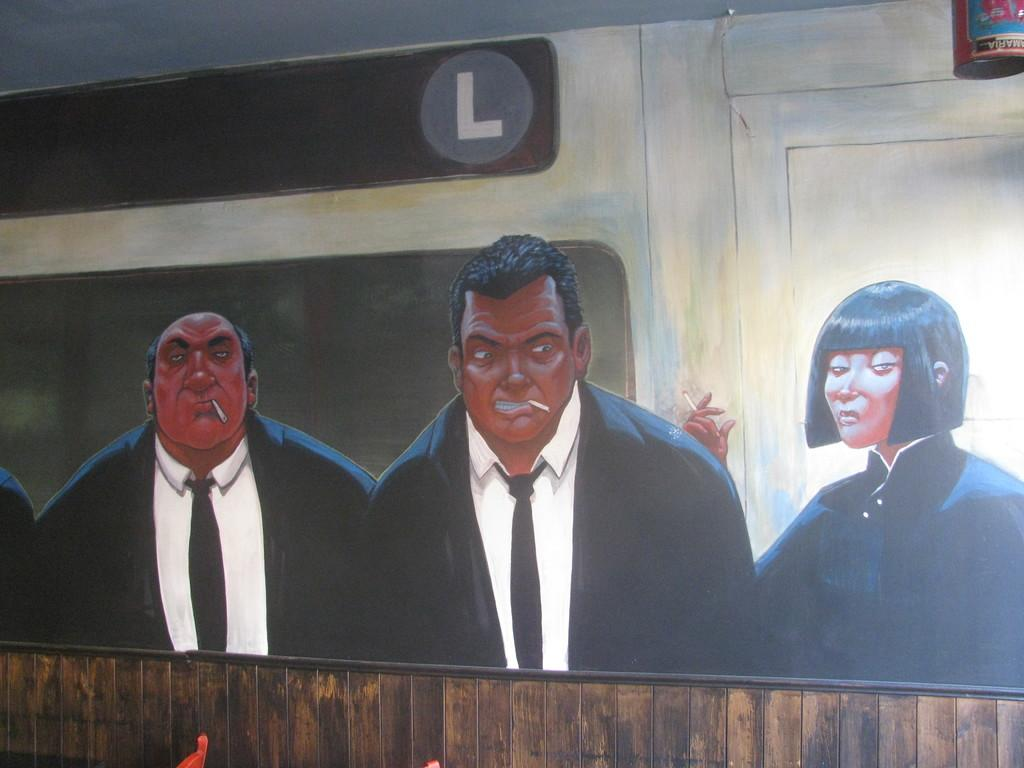What is depicted on the wall in the image? There is a picture on a wall in the image. Who or what is shown in the picture? The picture contains two men and a woman. What is the woman holding in the picture? The woman is holding cigarettes. What can be seen in the right corner of the image? There is a container in the right corner of the image. What type of ear is visible on the woman in the picture? There is no ear visible on the woman in the picture; only her holding cigarettes is depicted. 